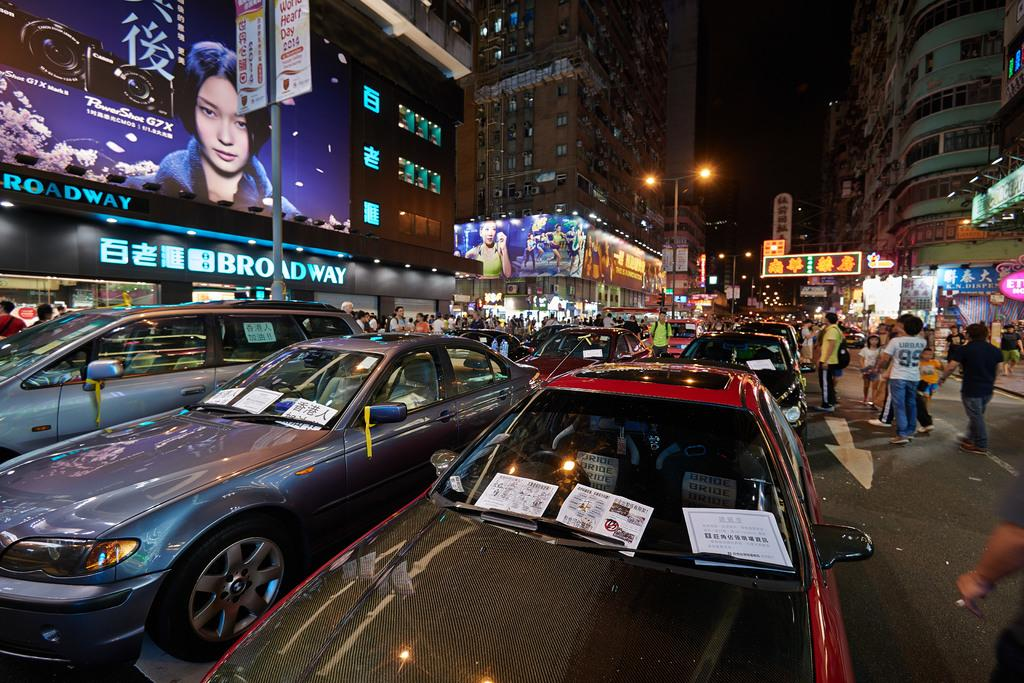<image>
Give a short and clear explanation of the subsequent image. a photo of a lady on the street above a Broadway sign 